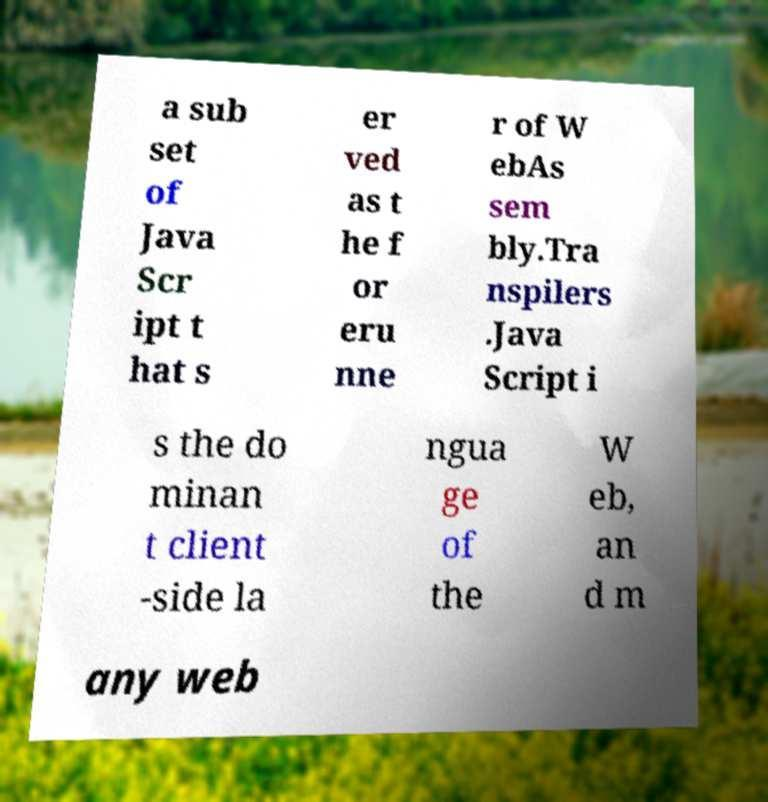Can you accurately transcribe the text from the provided image for me? a sub set of Java Scr ipt t hat s er ved as t he f or eru nne r of W ebAs sem bly.Tra nspilers .Java Script i s the do minan t client -side la ngua ge of the W eb, an d m any web 